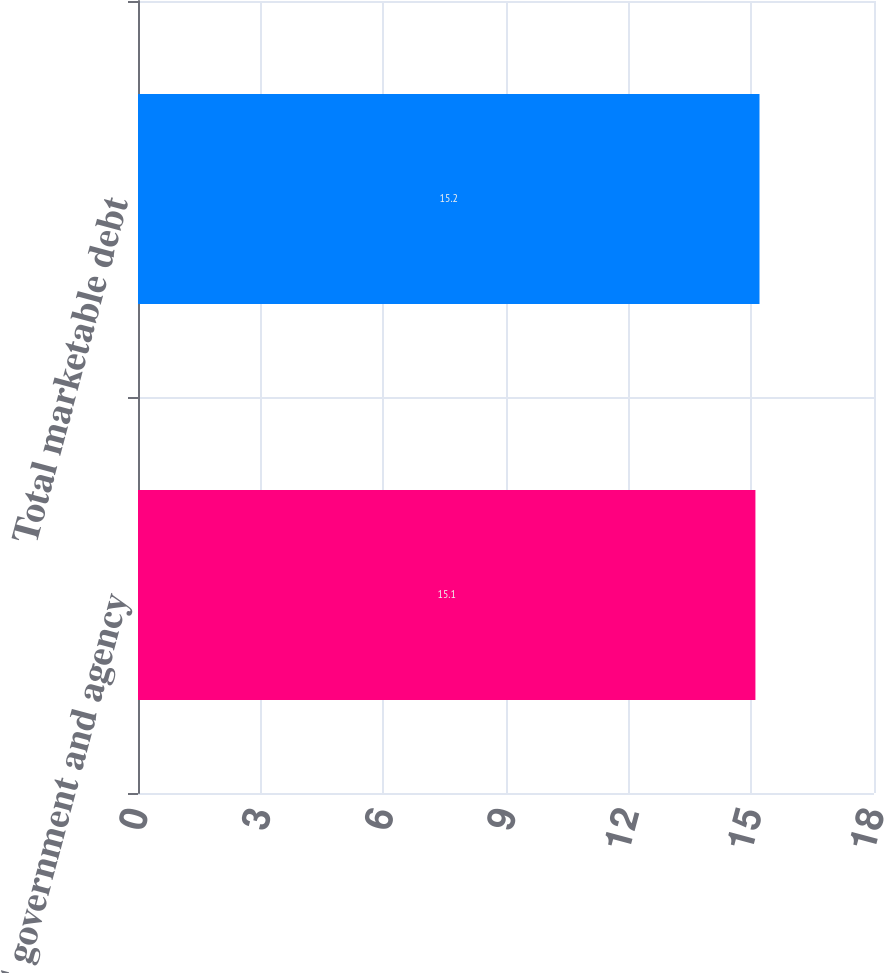<chart> <loc_0><loc_0><loc_500><loc_500><bar_chart><fcel>US government and agency<fcel>Total marketable debt<nl><fcel>15.1<fcel>15.2<nl></chart> 